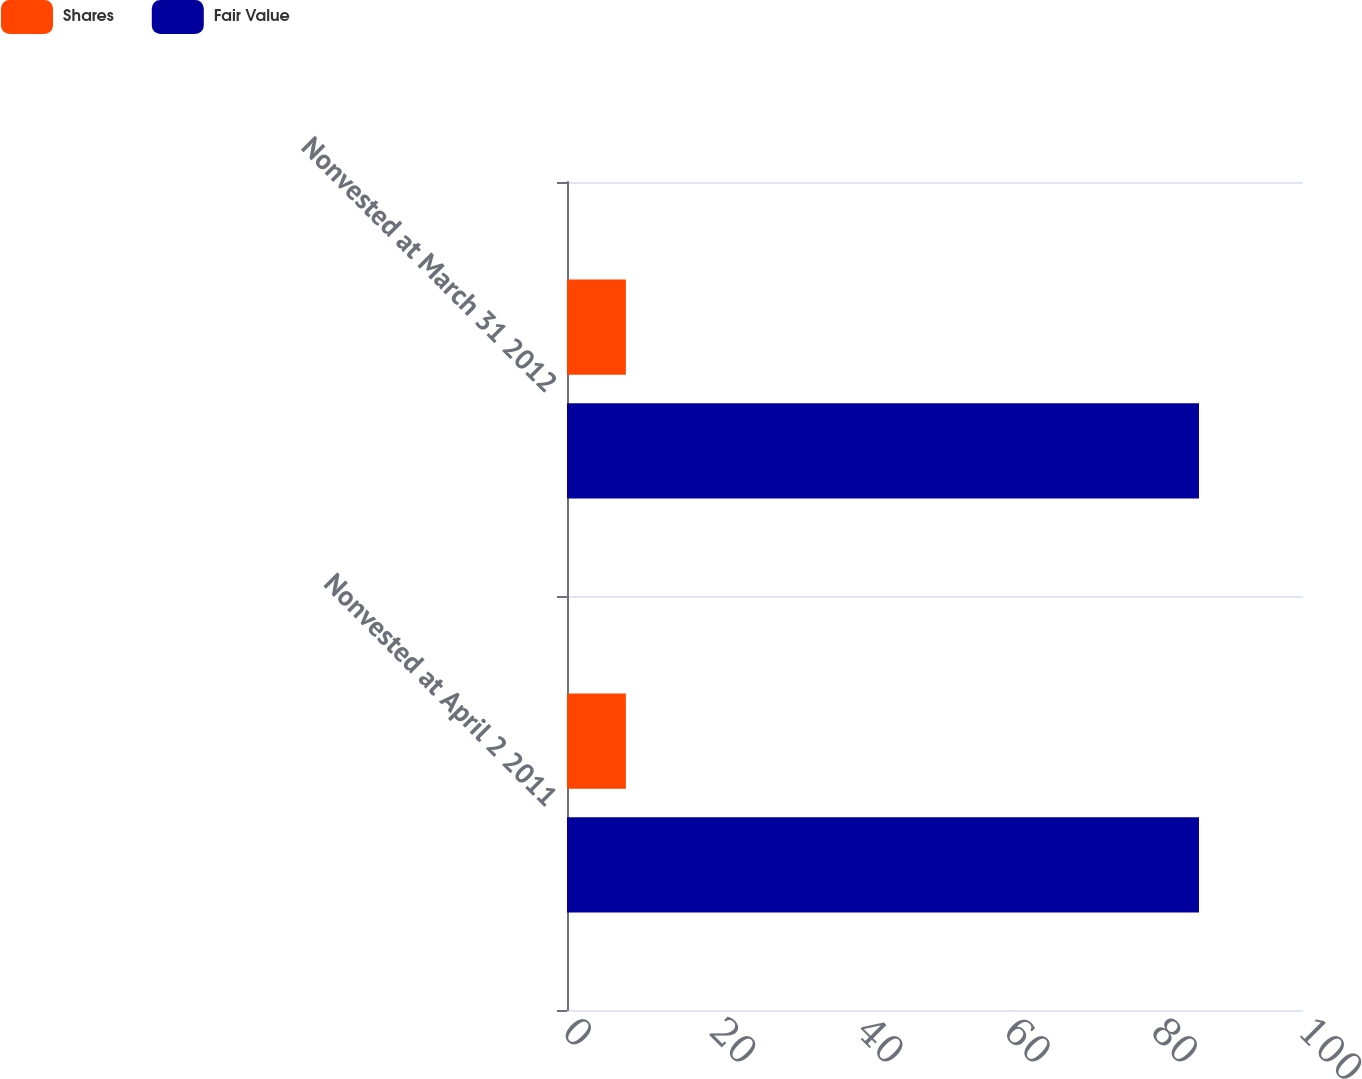Convert chart. <chart><loc_0><loc_0><loc_500><loc_500><stacked_bar_chart><ecel><fcel>Nonvested at April 2 2011<fcel>Nonvested at March 31 2012<nl><fcel>Shares<fcel>8<fcel>8<nl><fcel>Fair Value<fcel>85.87<fcel>85.87<nl></chart> 